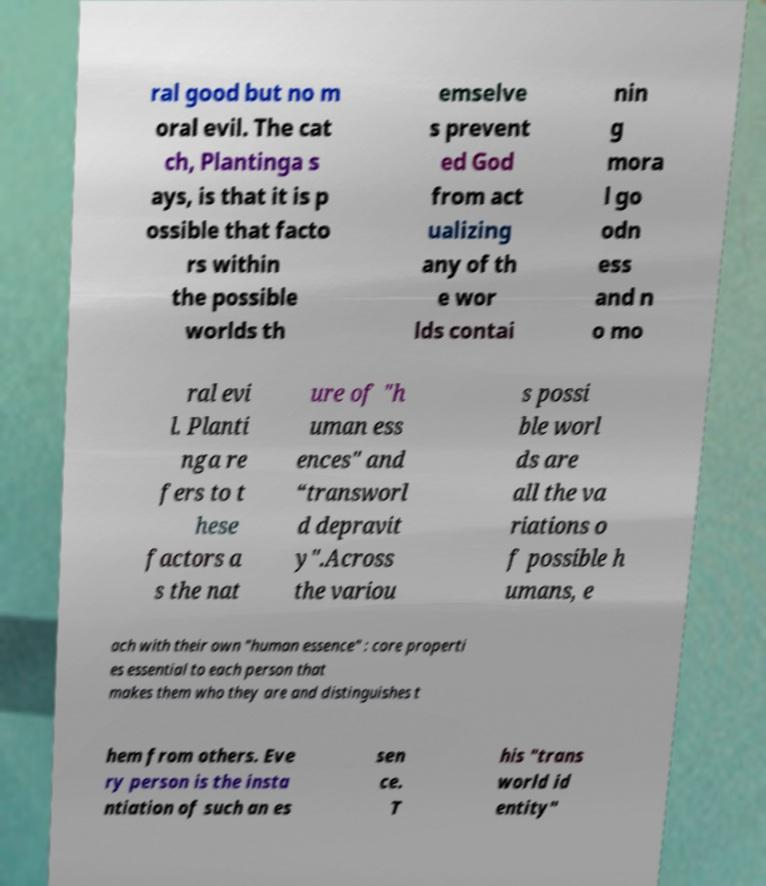Please read and relay the text visible in this image. What does it say? ral good but no m oral evil. The cat ch, Plantinga s ays, is that it is p ossible that facto rs within the possible worlds th emselve s prevent ed God from act ualizing any of th e wor lds contai nin g mora l go odn ess and n o mo ral evi l. Planti nga re fers to t hese factors a s the nat ure of "h uman ess ences" and “transworl d depravit y".Across the variou s possi ble worl ds are all the va riations o f possible h umans, e ach with their own "human essence" : core properti es essential to each person that makes them who they are and distinguishes t hem from others. Eve ry person is the insta ntiation of such an es sen ce. T his "trans world id entity" 